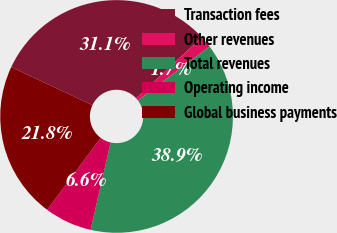<chart> <loc_0><loc_0><loc_500><loc_500><pie_chart><fcel>Transaction fees<fcel>Other revenues<fcel>Total revenues<fcel>Operating income<fcel>Global business payments<nl><fcel>31.11%<fcel>1.65%<fcel>38.85%<fcel>6.59%<fcel>21.79%<nl></chart> 